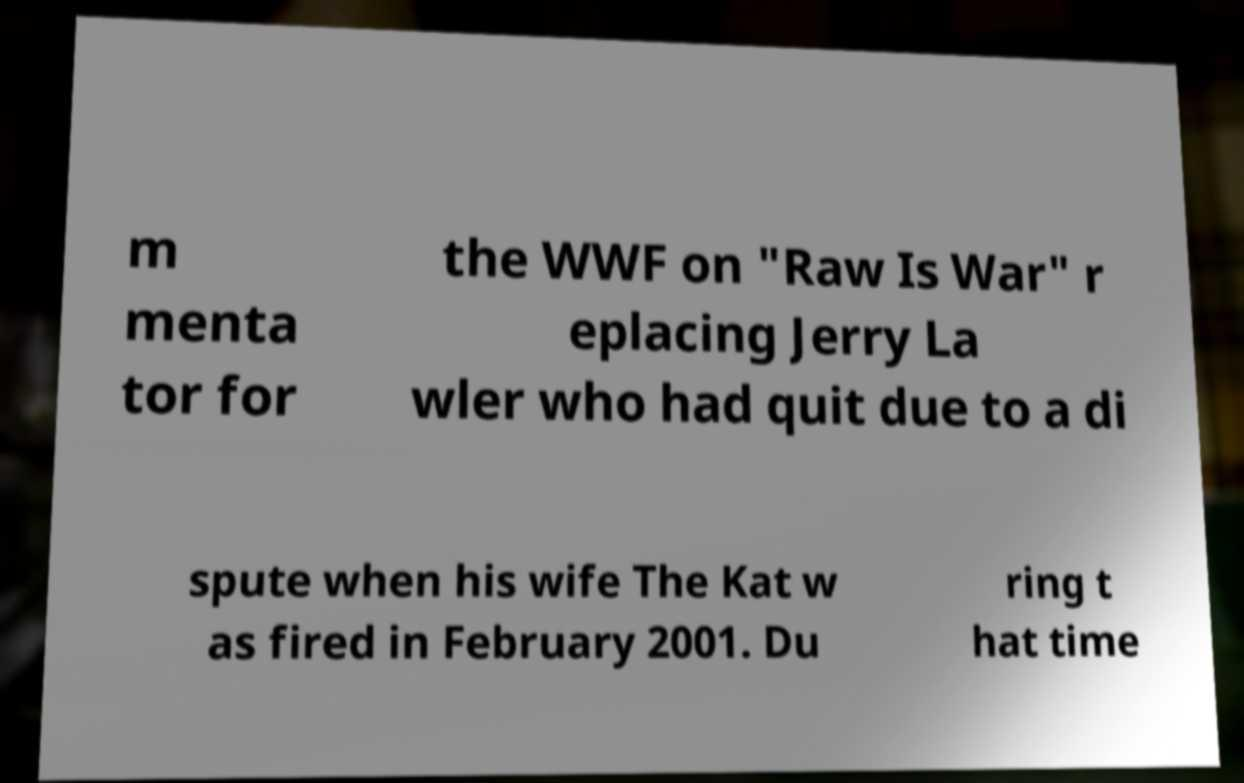I need the written content from this picture converted into text. Can you do that? m menta tor for the WWF on "Raw Is War" r eplacing Jerry La wler who had quit due to a di spute when his wife The Kat w as fired in February 2001. Du ring t hat time 